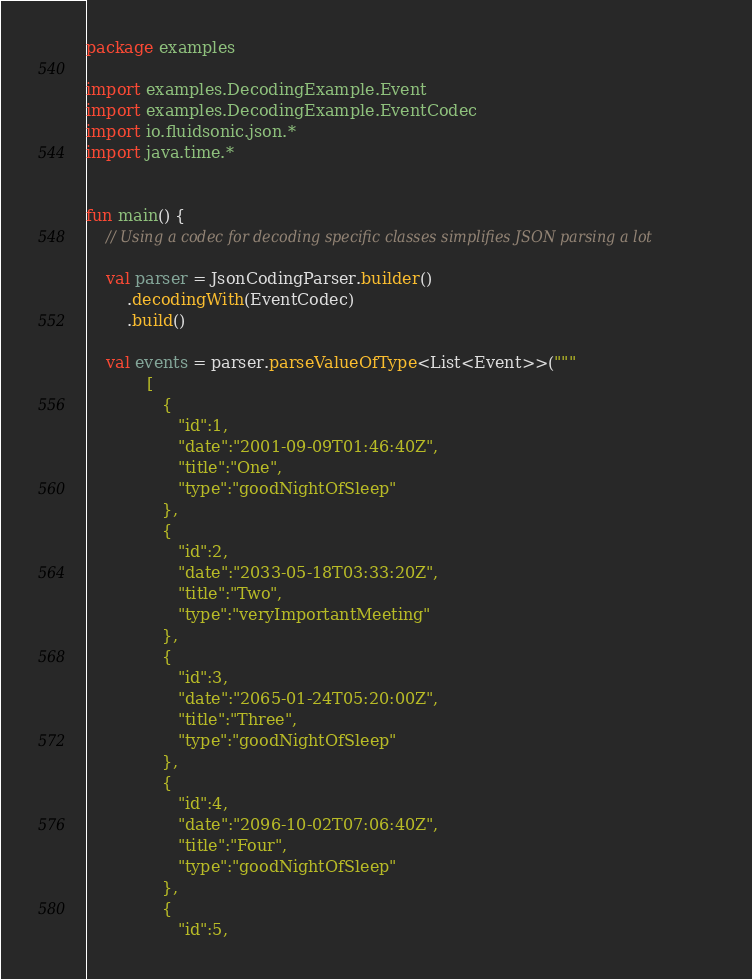<code> <loc_0><loc_0><loc_500><loc_500><_Kotlin_>package examples

import examples.DecodingExample.Event
import examples.DecodingExample.EventCodec
import io.fluidsonic.json.*
import java.time.*


fun main() {
	// Using a codec for decoding specific classes simplifies JSON parsing a lot

	val parser = JsonCodingParser.builder()
		.decodingWith(EventCodec)
		.build()

	val events = parser.parseValueOfType<List<Event>>("""
			[
			   {
			      "id":1,
			      "date":"2001-09-09T01:46:40Z",
			      "title":"One",
				  "type":"goodNightOfSleep"
			   },
			   {
			      "id":2,
			      "date":"2033-05-18T03:33:20Z",
			      "title":"Two",
				  "type":"veryImportantMeeting"
			   },
			   {
			      "id":3,
			      "date":"2065-01-24T05:20:00Z",
			      "title":"Three",
				  "type":"goodNightOfSleep"
			   },
			   {
			      "id":4,
			      "date":"2096-10-02T07:06:40Z",
			      "title":"Four",
				  "type":"goodNightOfSleep"
			   },
			   {
			      "id":5,</code> 